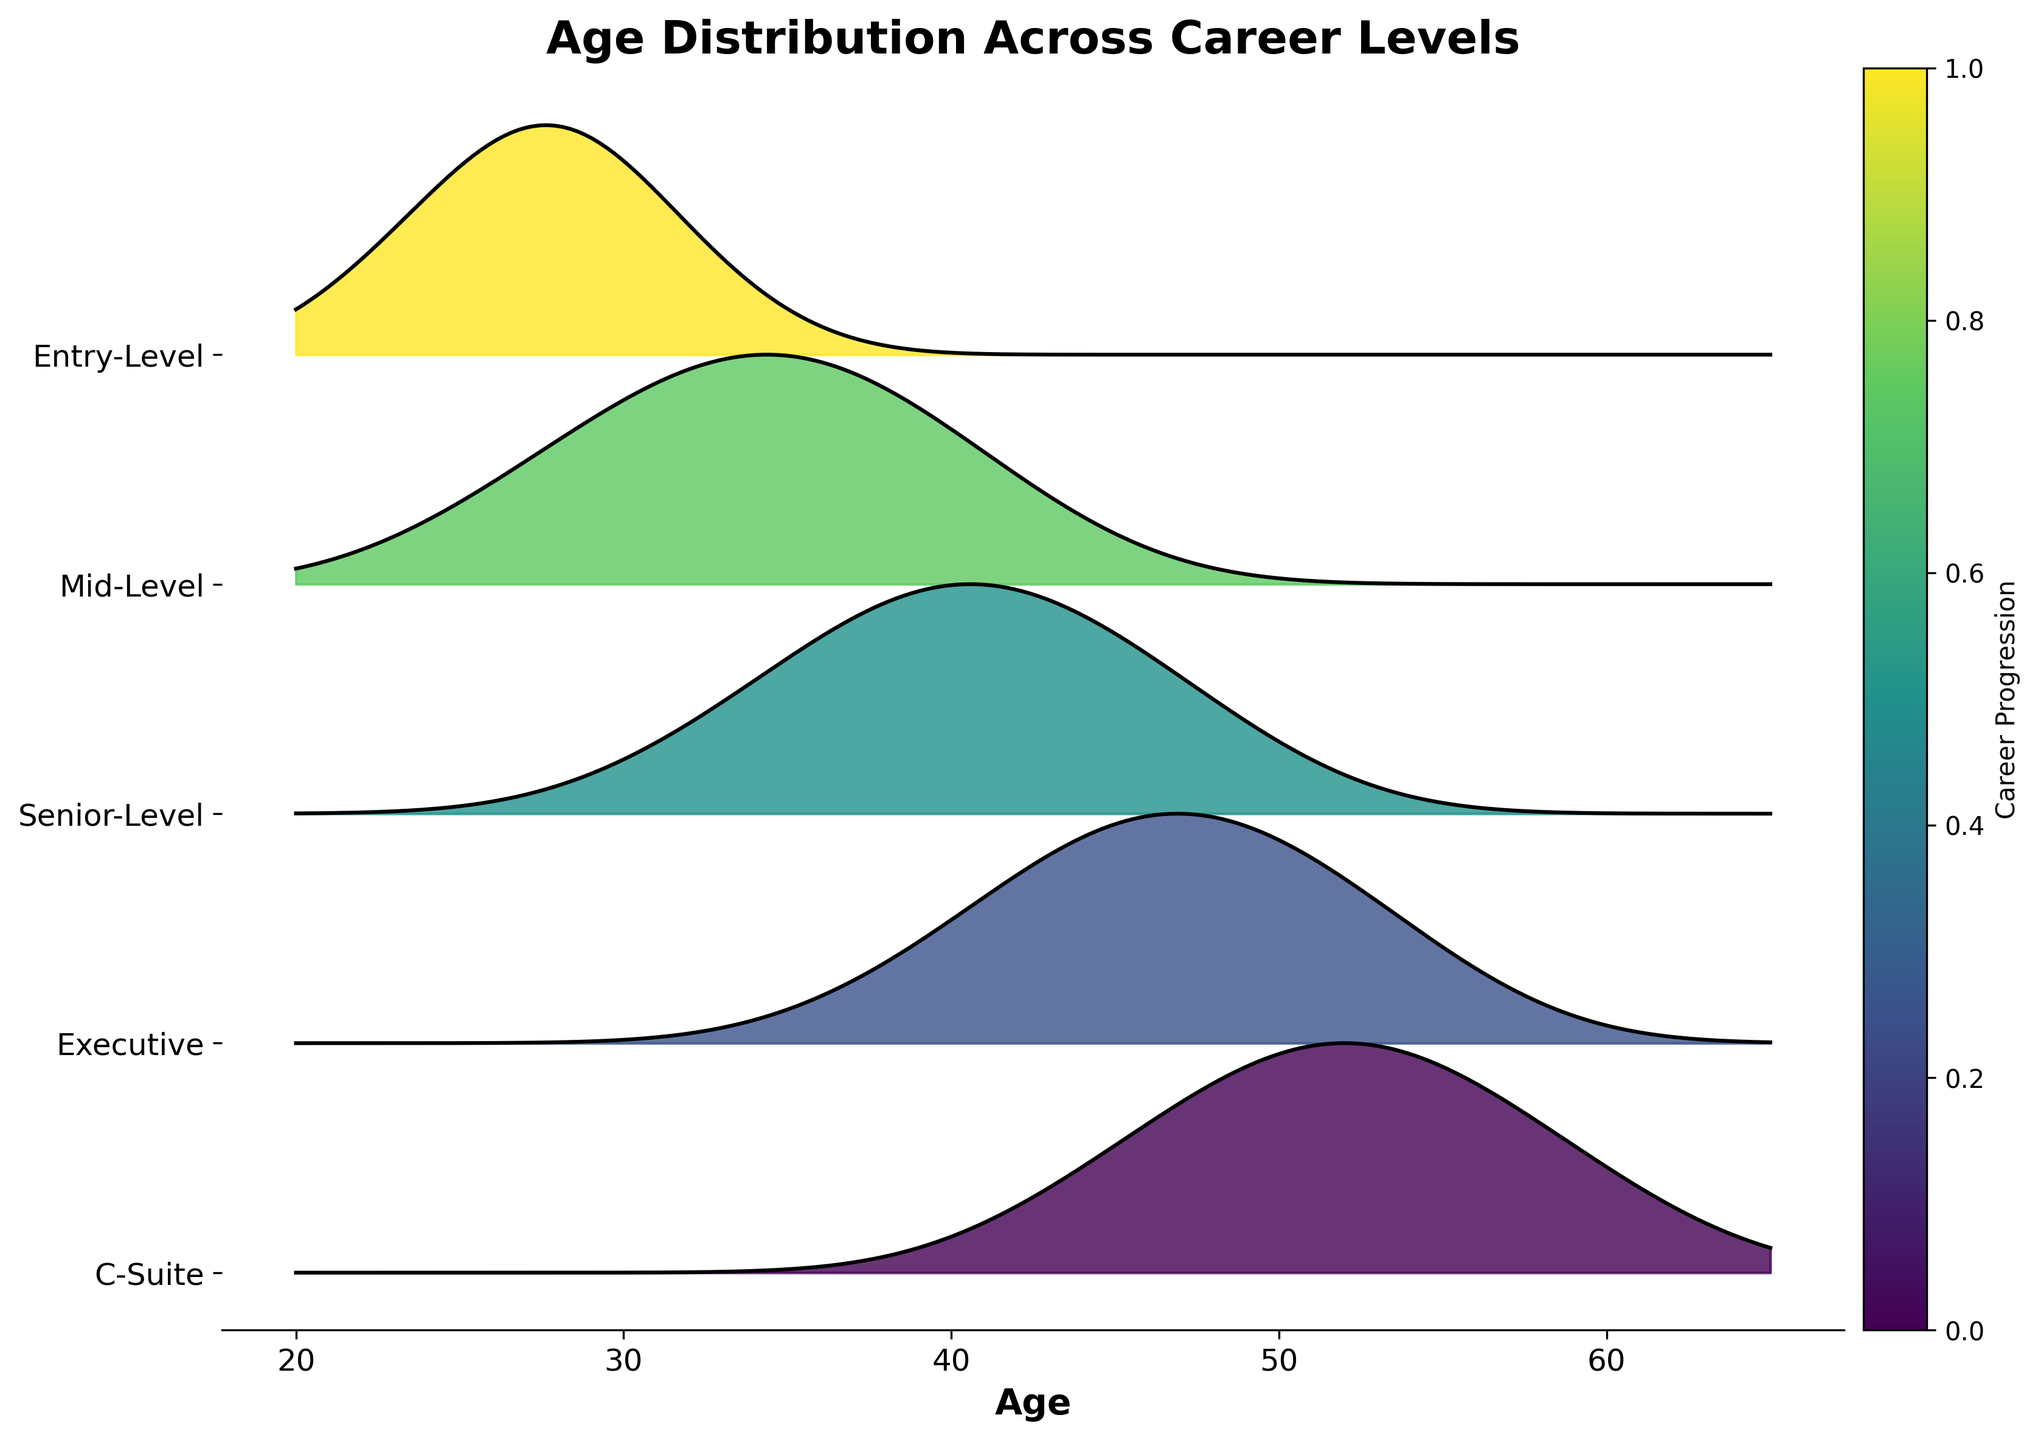What is the title of the figure? The title is usually displayed prominently at the top of the figure.
Answer: Age Distribution Across Career Levels Which axis shows the age distribution? The horizontal axis, which displays the variations in age, shows the age distribution.
Answer: Horizontal axis How many career levels are displayed in the figure? Count the unique labels along the vertical axis, which represent different career levels.
Answer: Five At which career level does the highest density occur at age 40? To find this, locate age 40 on the horizontal axis and see which career level aligns with the highest point.
Answer: Senior-Level What is the general trend in the age distribution as one progresses from Entry-Level to C-Suite? Look at the ages and densities for each career level in ascending order to observe the overall pattern.
Answer: Increases Which career level has the widest range of ages? Examine the horizontal spread of density for each career level and identify the one with the largest age range.
Answer: C-Suite At what age does the density peak for the Mid-Level group? Locate the highest point on the ridge for the Mid-Level group and identify the corresponding age.
Answer: 34 How does the peak age for the Executive group compare to the peak age for the C-Suite group? Identify the peak ages for both groups and compare them.
Answer: The Executive group's peak occurs at age 46, while the C-Suite group's peak occurs at age 52 Which career level has a noticeable density at age 60? Look at the age 60 mark on the horizontal axis and see if any career levels have a notable density there.
Answer: C-Suite What is the age range of the Entry-Level group according to the figure? Identify the span of ages covered by the density distribution for the Entry-Level group.
Answer: 22 to 34 